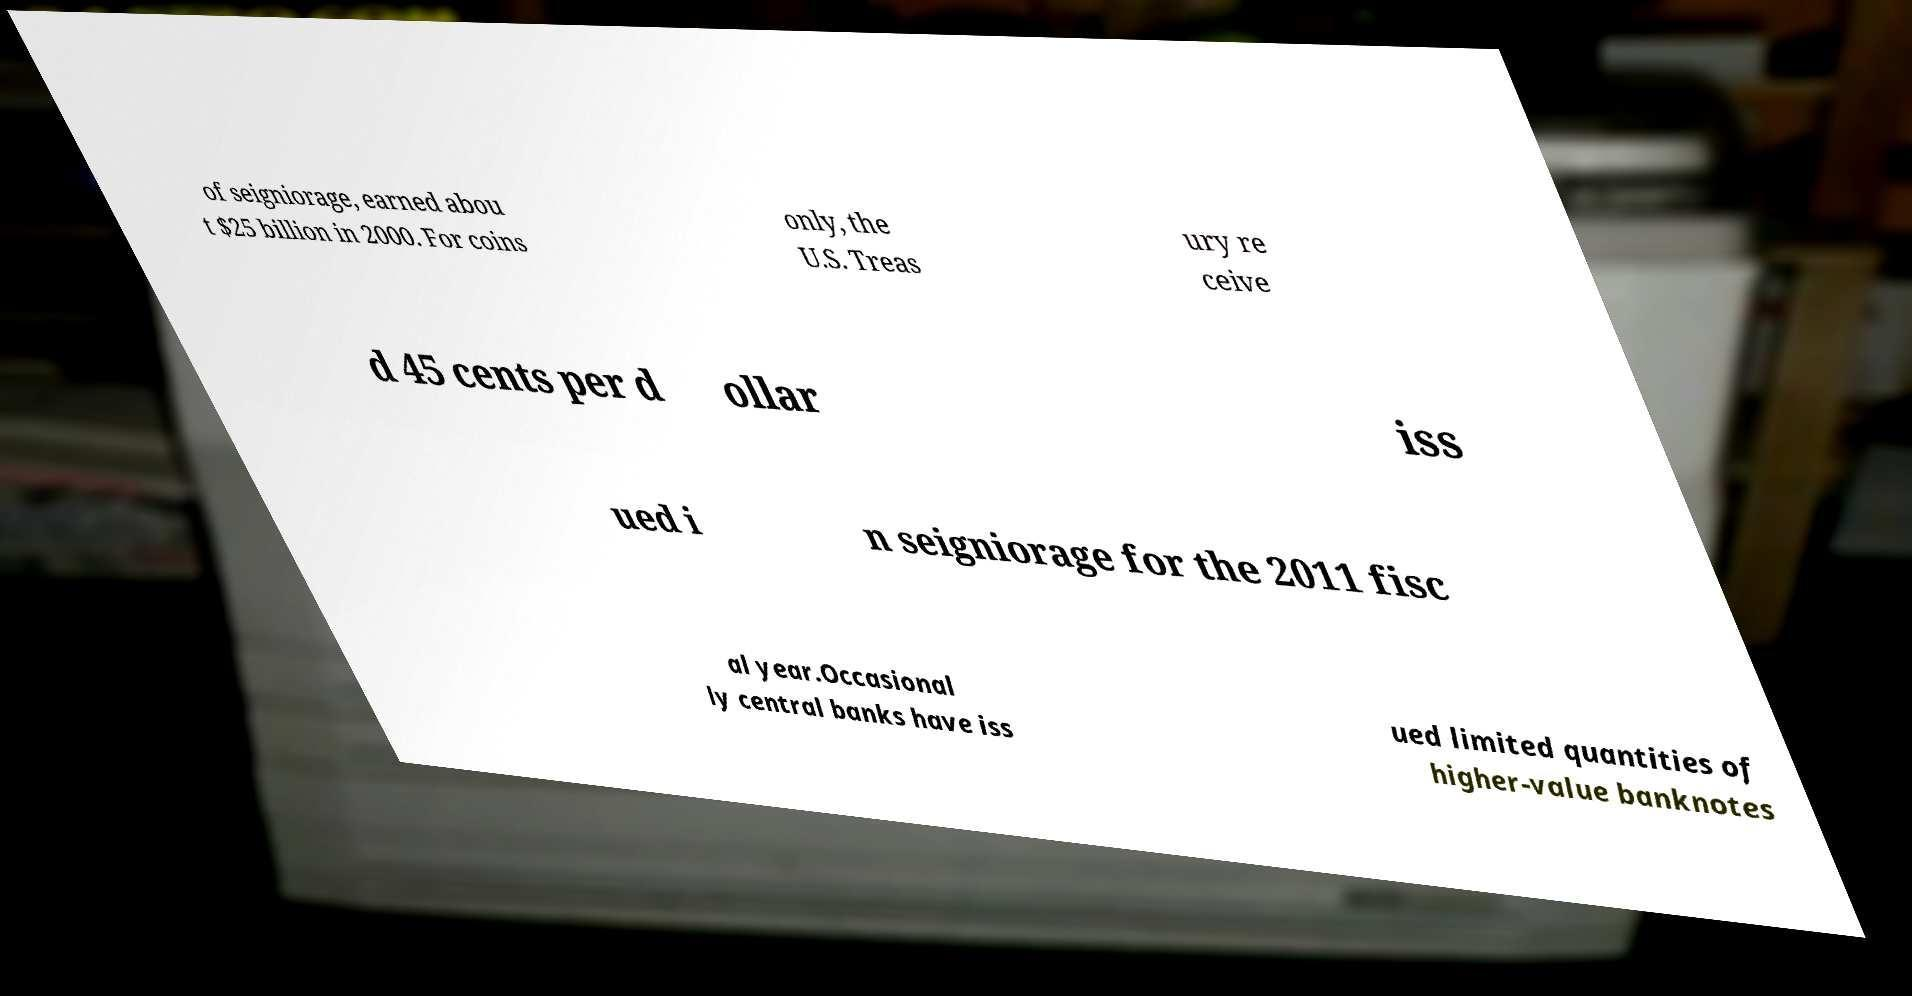For documentation purposes, I need the text within this image transcribed. Could you provide that? of seigniorage, earned abou t $25 billion in 2000. For coins only, the U.S. Treas ury re ceive d 45 cents per d ollar iss ued i n seigniorage for the 2011 fisc al year.Occasional ly central banks have iss ued limited quantities of higher-value banknotes 